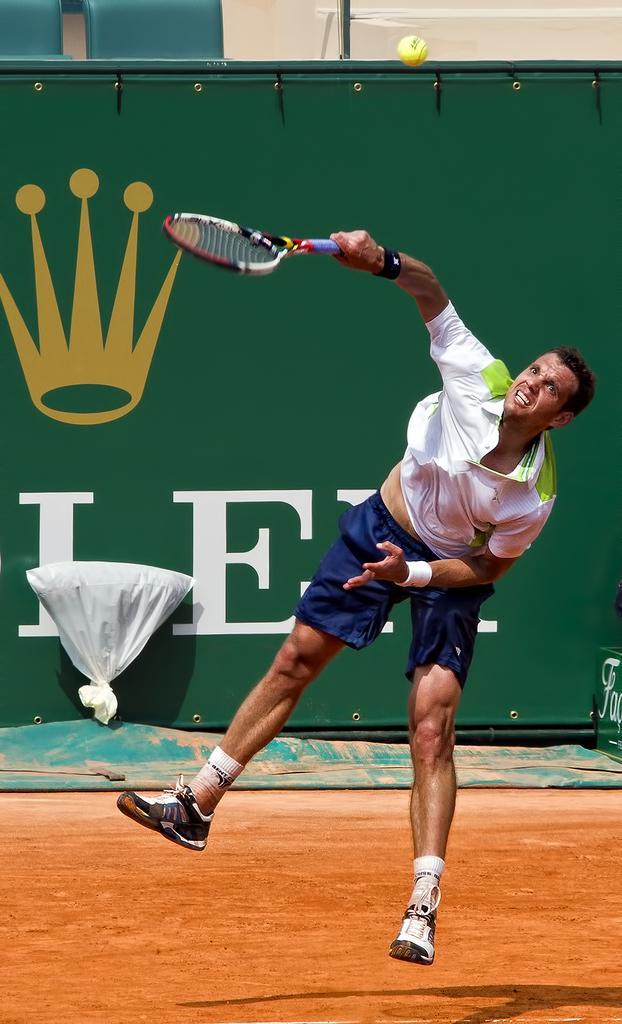Describe this image in one or two sentences. There is a sports person wearing white color T-shirt and holding a racket in his hand and at the top of the image there is a ball. 